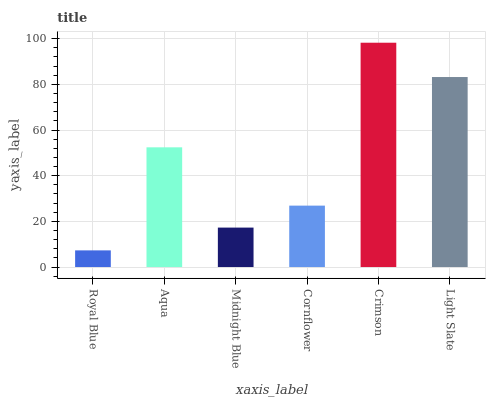Is Royal Blue the minimum?
Answer yes or no. Yes. Is Crimson the maximum?
Answer yes or no. Yes. Is Aqua the minimum?
Answer yes or no. No. Is Aqua the maximum?
Answer yes or no. No. Is Aqua greater than Royal Blue?
Answer yes or no. Yes. Is Royal Blue less than Aqua?
Answer yes or no. Yes. Is Royal Blue greater than Aqua?
Answer yes or no. No. Is Aqua less than Royal Blue?
Answer yes or no. No. Is Aqua the high median?
Answer yes or no. Yes. Is Cornflower the low median?
Answer yes or no. Yes. Is Cornflower the high median?
Answer yes or no. No. Is Crimson the low median?
Answer yes or no. No. 